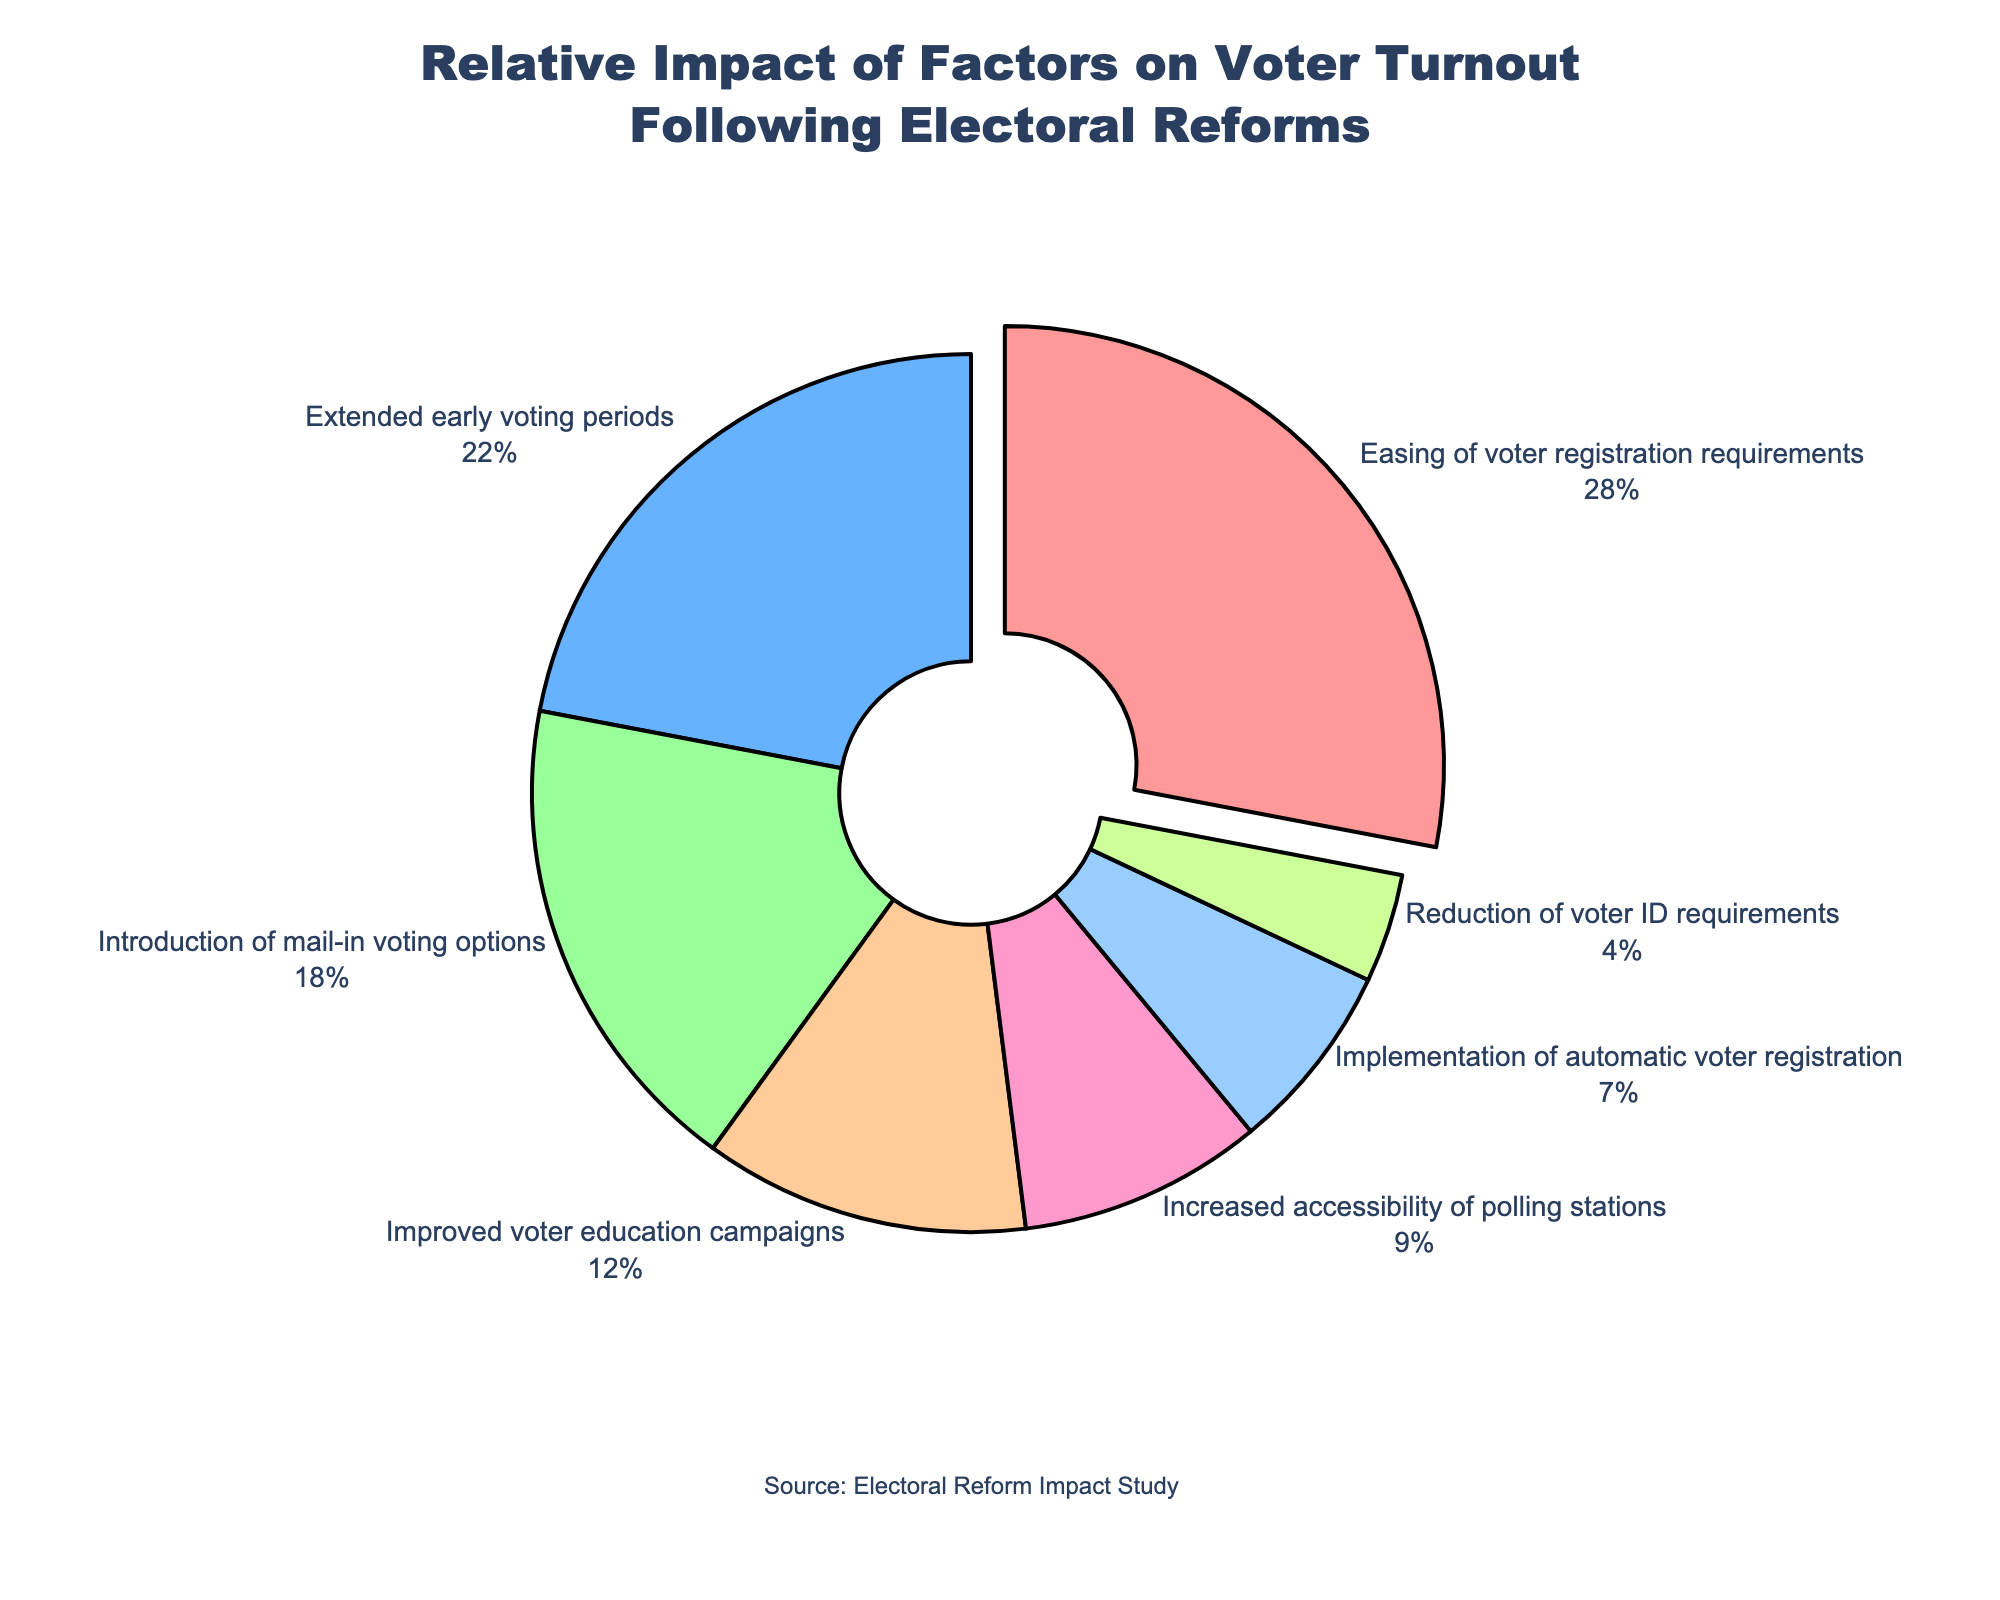Which factor has the highest relative impact on voter turnout according to the pie chart? The pie chart segment labeled "Easing of voter registration requirements" is the largest, representing 28% of the total.
Answer: Easing of voter registration requirements What is the combined percentage of the factors related to voting options (mail-in voting and early voting)? Add the percentage of "Introduction of mail-in voting options" (18%) and "Extended early voting periods" (22%) segments. 18 + 22 = 40
Answer: 40 Which factor has the smallest relative impact on voter turnout? The pie chart segment labeled "Reduction of voter ID requirements" is the smallest, which represents 4%.
Answer: Reduction of voter ID requirements How does the impact of "Improved voter education campaigns" compare to "Increased accessibility of polling stations"? Compare the segments labeled "Improved voter education campaigns" (12%) and "Increased accessibility of polling stations" (9%). 12% is greater than 9%.
Answer: Improved voter education campaigns have a greater impact If we combine the impacts of "Improved voter education campaigns", "Increased accessibility of polling stations", and "Implementation of automatic voter registration", what would be the total percentage? Add the percentages: 12 (Improved voter education campaigns) + 9 (Increased accessibility of polling stations) + 7 (Implementation of automatic voter registration). 12 + 9 + 7 = 28
Answer: 28 What percentage represents the difference between the impacts of "Extended early voting periods" and "Reduction of voter ID requirements"? Subtract "Reduction of voter ID requirements" percentage (4%) from "Extended early voting periods" percentage (22%). 22 - 4 = 18
Answer: 18 Which factor is depicted with a yellow slice? Identify the yellow color slice labeled as "Extended early voting periods", which represents 22%.
Answer: Extended early voting periods If factors with an impact below 10% are grouped, what percentage do they collectively represent? Sum the percentages of "Increased accessibility of polling stations" (9%), "Implementation of automatic voter registration" (7%), and "Reduction of voter ID requirements" (4%). 9 + 7 + 4 = 20
Answer: 20 Which factor has a visual distinction (pulled out) in the pie chart? The visually distinct segment that is pulled out from the rest is "Easing of voter registration requirements".
Answer: Easing of voter registration requirements 